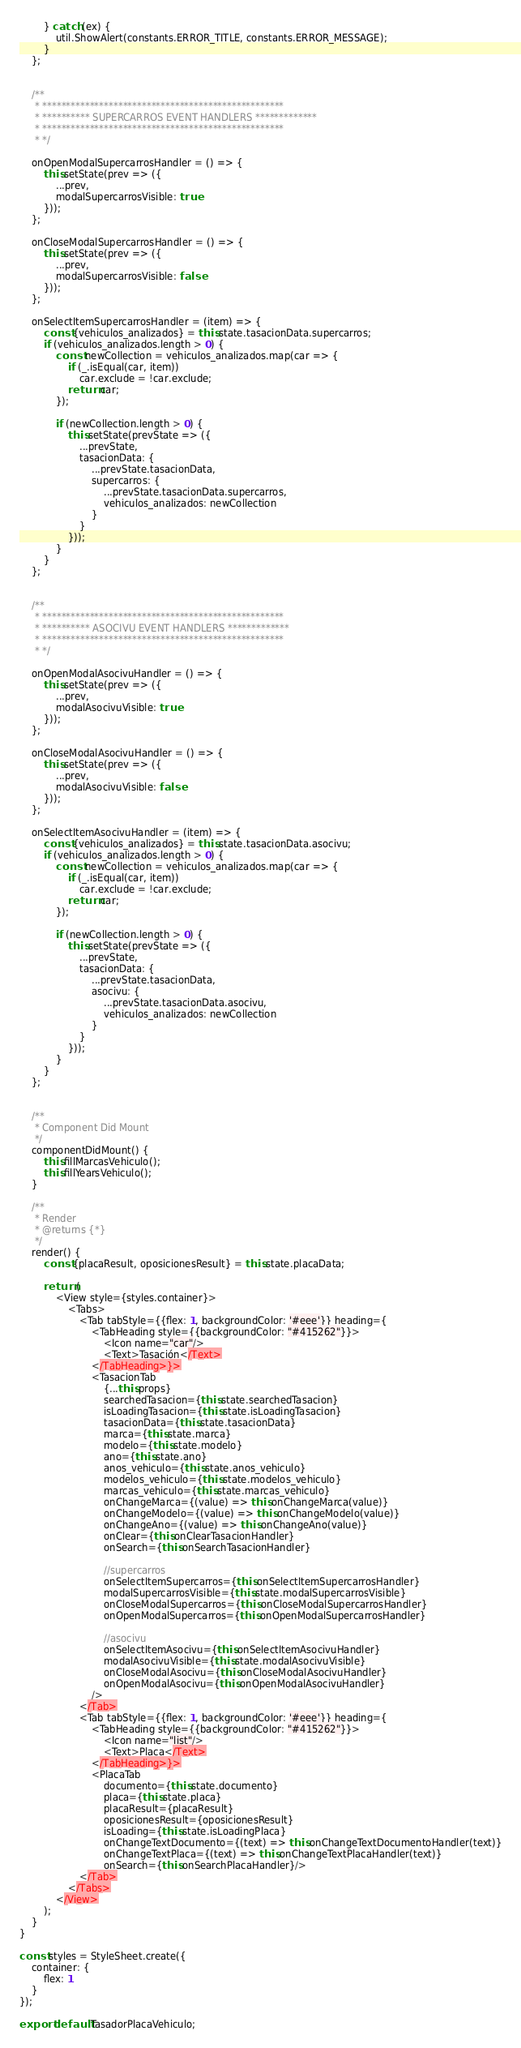<code> <loc_0><loc_0><loc_500><loc_500><_JavaScript_>        } catch (ex) {
            util.ShowAlert(constants.ERROR_TITLE, constants.ERROR_MESSAGE);
        }
    };


    /**
     * ***************************************************
     * ********** SUPERCARROS EVENT HANDLERS *************
     * ***************************************************
     * */

    onOpenModalSupercarrosHandler = () => {
        this.setState(prev => ({
            ...prev,
            modalSupercarrosVisible: true
        }));
    };

    onCloseModalSupercarrosHandler = () => {
        this.setState(prev => ({
            ...prev,
            modalSupercarrosVisible: false
        }));
    };

    onSelectItemSupercarrosHandler = (item) => {
        const {vehiculos_analizados} = this.state.tasacionData.supercarros;
        if (vehiculos_analizados.length > 0) {
            const newCollection = vehiculos_analizados.map(car => {
                if (_.isEqual(car, item))
                    car.exclude = !car.exclude;
                return car;
            });

            if (newCollection.length > 0) {
                this.setState(prevState => ({
                    ...prevState,
                    tasacionData: {
                        ...prevState.tasacionData,
                        supercarros: {
                            ...prevState.tasacionData.supercarros,
                            vehiculos_analizados: newCollection
                        }
                    }
                }));
            }
        }
    };


    /**
     * ***************************************************
     * ********** ASOCIVU EVENT HANDLERS *************
     * ***************************************************
     * */

    onOpenModalAsocivuHandler = () => {
        this.setState(prev => ({
            ...prev,
            modalAsocivuVisible: true
        }));
    };

    onCloseModalAsocivuHandler = () => {
        this.setState(prev => ({
            ...prev,
            modalAsocivuVisible: false
        }));
    };

    onSelectItemAsocivuHandler = (item) => {
        const {vehiculos_analizados} = this.state.tasacionData.asocivu;
        if (vehiculos_analizados.length > 0) {
            const newCollection = vehiculos_analizados.map(car => {
                if (_.isEqual(car, item))
                    car.exclude = !car.exclude;
                return car;
            });

            if (newCollection.length > 0) {
                this.setState(prevState => ({
                    ...prevState,
                    tasacionData: {
                        ...prevState.tasacionData,
                        asocivu: {
                            ...prevState.tasacionData.asocivu,
                            vehiculos_analizados: newCollection
                        }
                    }
                }));
            }
        }
    };


    /**
     * Component Did Mount
     */
    componentDidMount() {
        this.fillMarcasVehiculo();
        this.fillYearsVehiculo();
    }

    /**
     * Render
     * @returns {*}
     */
    render() {
        const {placaResult, oposicionesResult} = this.state.placaData;

        return (
            <View style={styles.container}>
                <Tabs>
                    <Tab tabStyle={{flex: 1, backgroundColor: '#eee'}} heading={
                        <TabHeading style={{backgroundColor: "#415262"}}>
                            <Icon name="car"/>
                            <Text>Tasación</Text>
                        </TabHeading>}>
                        <TasacionTab
                            {...this.props}
                            searchedTasacion={this.state.searchedTasacion}
                            isLoadingTasacion={this.state.isLoadingTasacion}
                            tasacionData={this.state.tasacionData}
                            marca={this.state.marca}
                            modelo={this.state.modelo}
                            ano={this.state.ano}
                            anos_vehiculo={this.state.anos_vehiculo}
                            modelos_vehiculo={this.state.modelos_vehiculo}
                            marcas_vehiculo={this.state.marcas_vehiculo}
                            onChangeMarca={(value) => this.onChangeMarca(value)}
                            onChangeModelo={(value) => this.onChangeModelo(value)}
                            onChangeAno={(value) => this.onChangeAno(value)}
                            onClear={this.onClearTasacionHandler}
                            onSearch={this.onSearchTasacionHandler}

                            //supercarros
                            onSelectItemSupercarros={this.onSelectItemSupercarrosHandler}
                            modalSupercarrosVisible={this.state.modalSupercarrosVisible}
                            onCloseModalSupercarros={this.onCloseModalSupercarrosHandler}
                            onOpenModalSupercarros={this.onOpenModalSupercarrosHandler}

                            //asocivu
                            onSelectItemAsocivu={this.onSelectItemAsocivuHandler}
                            modalAsocivuVisible={this.state.modalAsocivuVisible}
                            onCloseModalAsocivu={this.onCloseModalAsocivuHandler}
                            onOpenModalAsocivu={this.onOpenModalAsocivuHandler}
                        />
                    </Tab>
                    <Tab tabStyle={{flex: 1, backgroundColor: '#eee'}} heading={
                        <TabHeading style={{backgroundColor: "#415262"}}>
                            <Icon name="list"/>
                            <Text>Placa</Text>
                        </TabHeading>}>
                        <PlacaTab
                            documento={this.state.documento}
                            placa={this.state.placa}
                            placaResult={placaResult}
                            oposicionesResult={oposicionesResult}
                            isLoading={this.state.isLoadingPlaca}
                            onChangeTextDocumento={(text) => this.onChangeTextDocumentoHandler(text)}
                            onChangeTextPlaca={(text) => this.onChangeTextPlacaHandler(text)}
                            onSearch={this.onSearchPlacaHandler}/>
                    </Tab>
                </Tabs>
            </View>
        );
    }
}

const styles = StyleSheet.create({
    container: {
        flex: 1
    }
});

export default TasadorPlacaVehiculo;</code> 